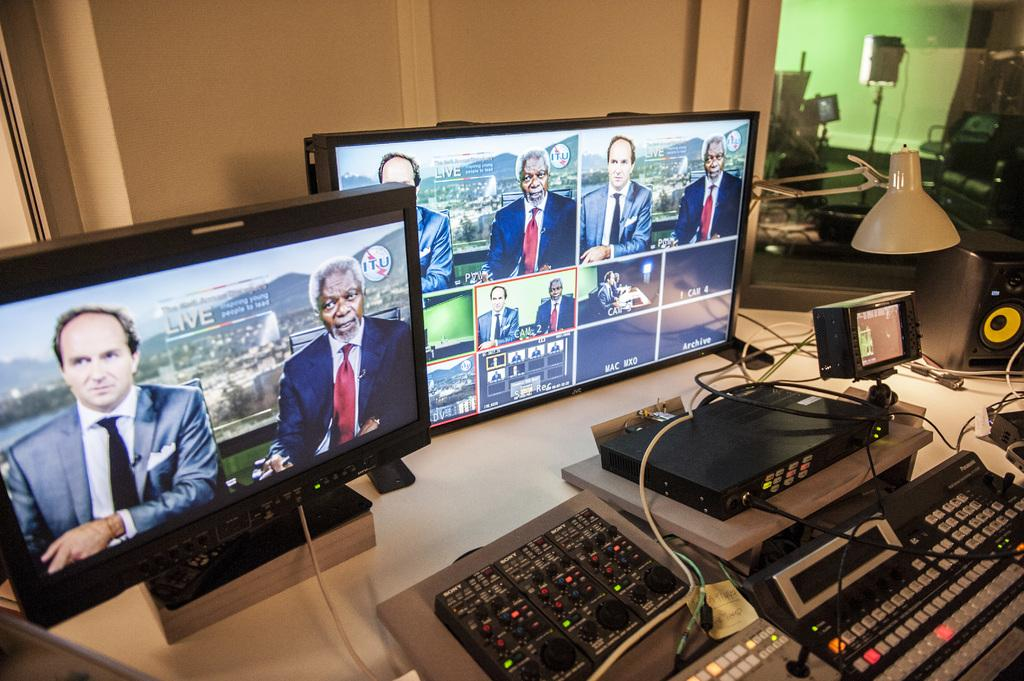<image>
Offer a succinct explanation of the picture presented. The monitor in front is showing a live discussion from ITU. 